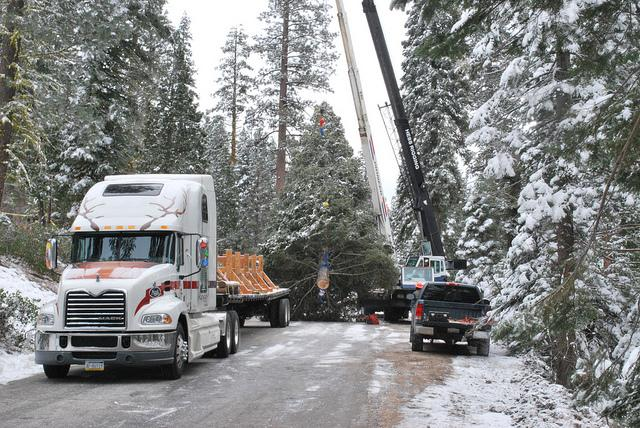What event is taking place here?

Choices:
A) car accident
B) snow storm
C) logging
D) road construction logging 